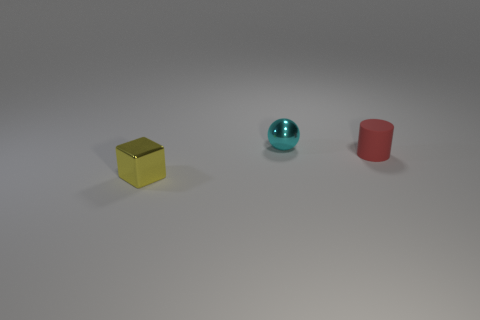Add 2 large brown shiny cylinders. How many objects exist? 5 Subtract all blocks. How many objects are left? 2 Subtract all tiny blue rubber blocks. Subtract all tiny yellow metal blocks. How many objects are left? 2 Add 3 spheres. How many spheres are left? 4 Add 3 big gray rubber cubes. How many big gray rubber cubes exist? 3 Subtract 0 brown blocks. How many objects are left? 3 